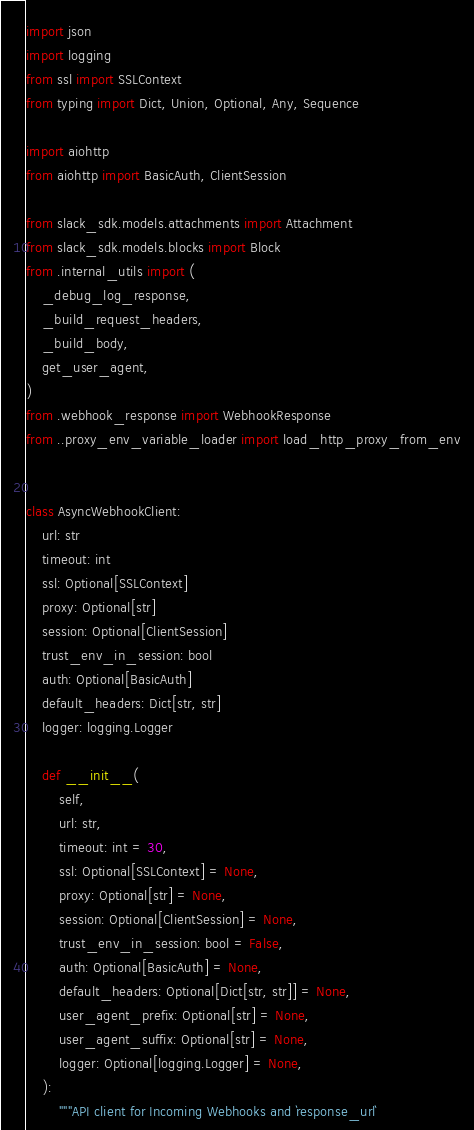<code> <loc_0><loc_0><loc_500><loc_500><_Python_>import json
import logging
from ssl import SSLContext
from typing import Dict, Union, Optional, Any, Sequence

import aiohttp
from aiohttp import BasicAuth, ClientSession

from slack_sdk.models.attachments import Attachment
from slack_sdk.models.blocks import Block
from .internal_utils import (
    _debug_log_response,
    _build_request_headers,
    _build_body,
    get_user_agent,
)
from .webhook_response import WebhookResponse
from ..proxy_env_variable_loader import load_http_proxy_from_env


class AsyncWebhookClient:
    url: str
    timeout: int
    ssl: Optional[SSLContext]
    proxy: Optional[str]
    session: Optional[ClientSession]
    trust_env_in_session: bool
    auth: Optional[BasicAuth]
    default_headers: Dict[str, str]
    logger: logging.Logger

    def __init__(
        self,
        url: str,
        timeout: int = 30,
        ssl: Optional[SSLContext] = None,
        proxy: Optional[str] = None,
        session: Optional[ClientSession] = None,
        trust_env_in_session: bool = False,
        auth: Optional[BasicAuth] = None,
        default_headers: Optional[Dict[str, str]] = None,
        user_agent_prefix: Optional[str] = None,
        user_agent_suffix: Optional[str] = None,
        logger: Optional[logging.Logger] = None,
    ):
        """API client for Incoming Webhooks and `response_url`
</code> 